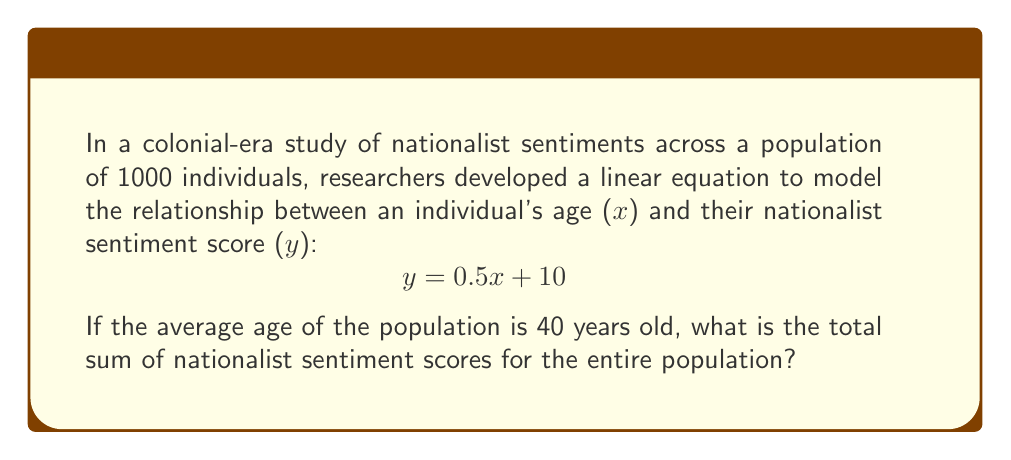Help me with this question. To solve this problem, we'll follow these steps:

1) The linear equation given is $y = 0.5x + 10$, where:
   $y$ = nationalist sentiment score
   $x$ = age of an individual

2) We're told that the average age of the population is 40 years. In a linear equation, we can use this average to calculate the average nationalist sentiment score:

   $y = 0.5(40) + 10$
   $y = 20 + 10 = 30$

3) So, the average nationalist sentiment score is 30.

4) Since we have a population of 1000 individuals, to find the total sum of nationalist sentiment scores, we multiply the average score by the population size:

   Total sum = Average score × Population size
   Total sum = $30 × 1000 = 30,000$

Therefore, the total sum of nationalist sentiment scores for the entire population is 30,000.
Answer: 30,000 